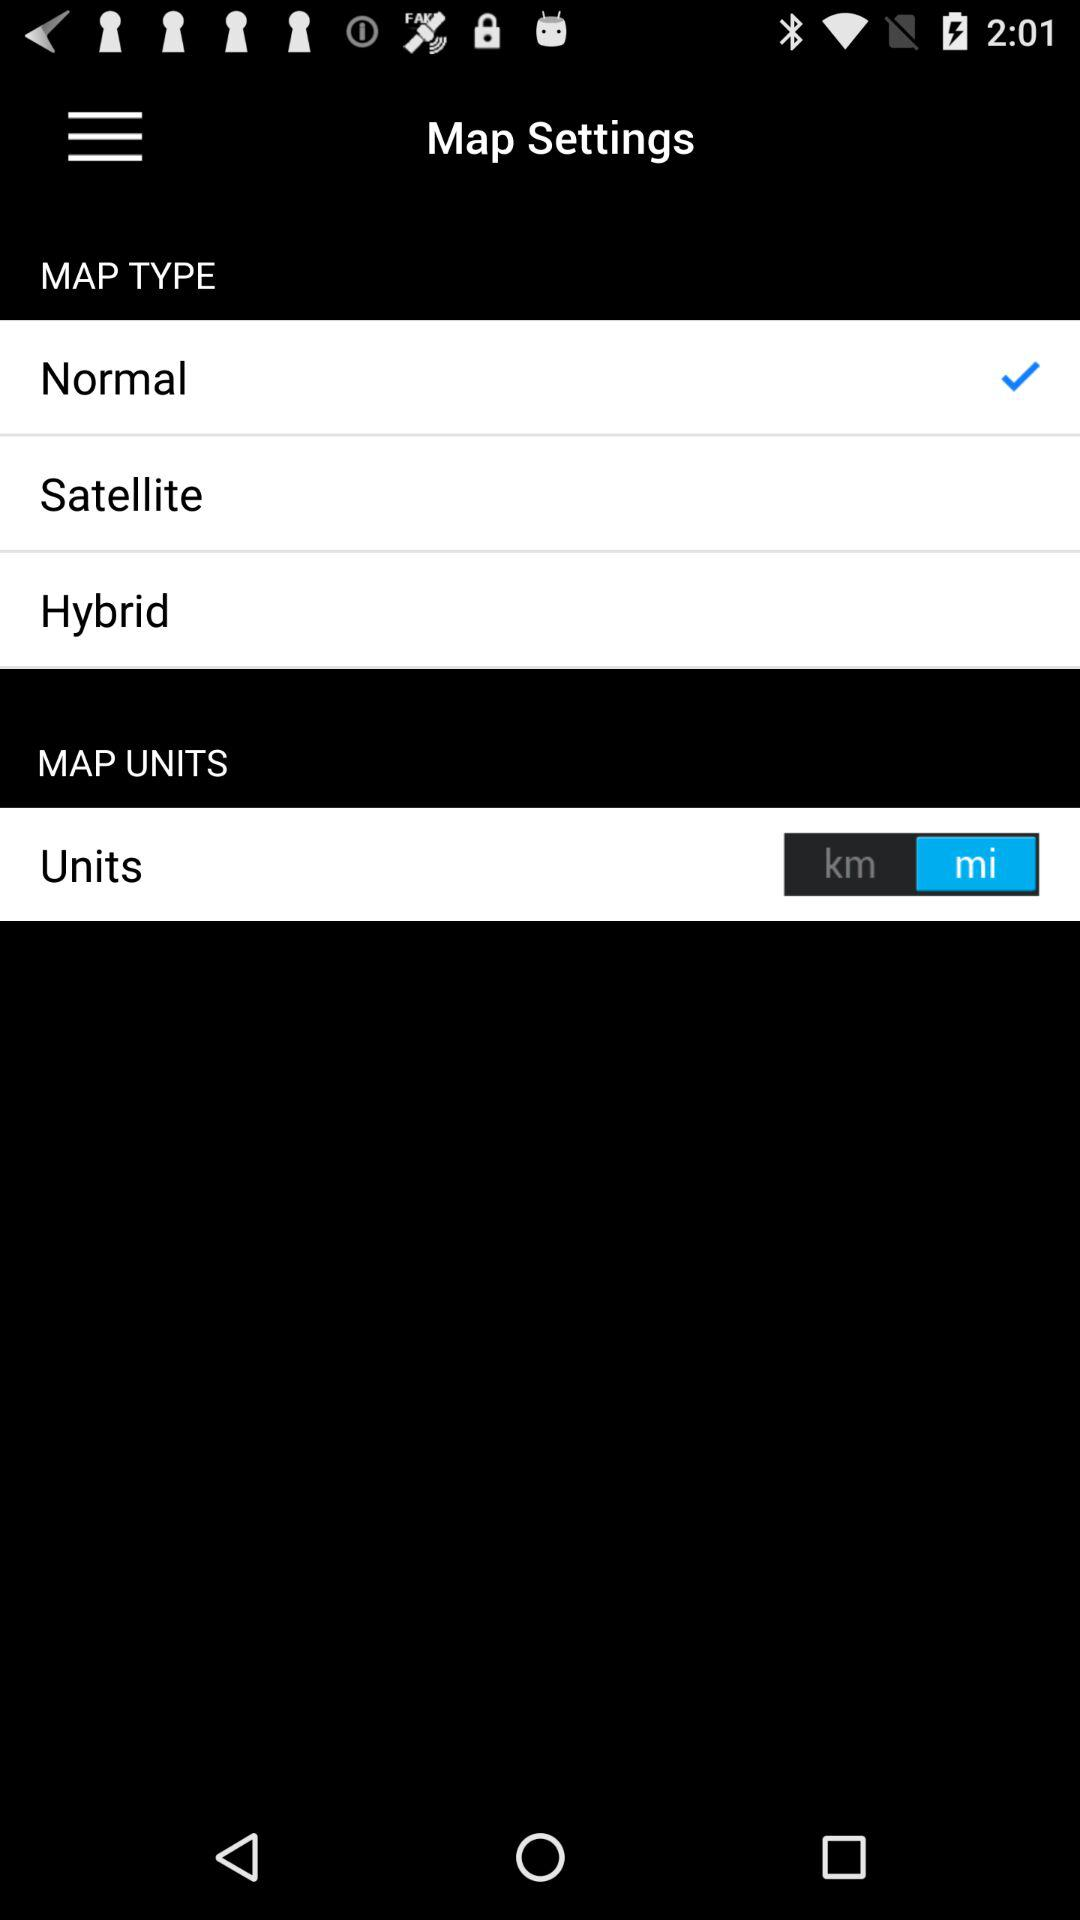Which is the selected map type? The selected map type is "Normal". 